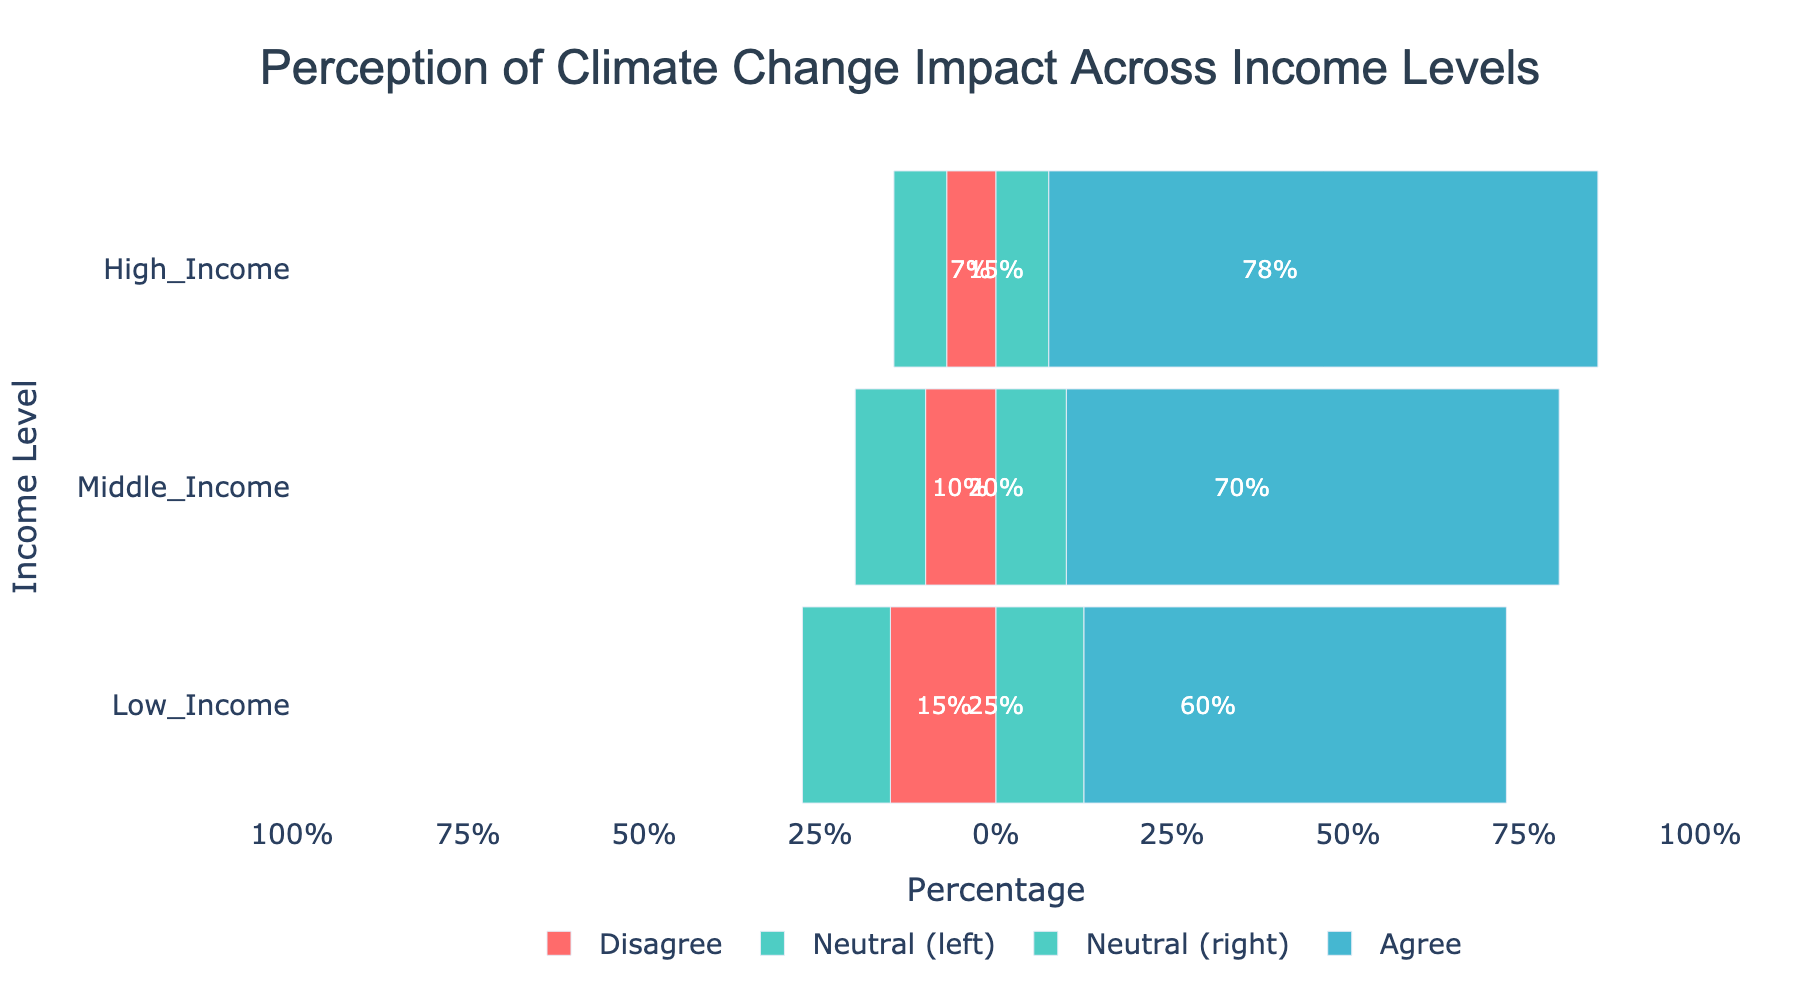What's the percentage of people who 'Agree' in the High Income level? To find this, look at the 'Agree' bar for the High Income level. The bar is labeled as 35%, which is the percentage of people who agree.
Answer: 35% Which income level has the highest percentage of people who 'Strongly Agree'? The income level with the highest 'Strongly Agree' percentage can be found by comparing the blue bars labeled 'Strongly Agree' across all income levels. The High Income level has the highest blue bar at 43%.
Answer: High Income What's the total percentage of people who are 'Neutral' in all income levels? Sum the 'Neutral' percentages across all income levels: 25% (Low Income) + 20% (Middle Income) + 15% (High Income) = 60%.
Answer: 60% Compare the total percentages of 'Strongly Disagree' and 'Strongly Agree' in the Low Income level. In the Low Income level, 'Strongly Disagree' is 5% and 'Strongly Agree' is 30%. The difference is 30% - 5% = 25%.
Answer: 25% Among all income levels, which one has the lowest percentage of people who 'Disagree'? Check the 'Disagree' percentages (seen in red bars) across all income levels. The High Income level has the lowest at 5%.
Answer: High Income What is the combined percentage of people who either 'Agree' or 'Strongly Agree' in the Middle Income level? The percentage who 'Agree' in Middle Income is 40%, and 'Strongly Agree' is 30%. So, 40% + 30% = 70%.
Answer: 70% Which income level has the most balanced perception, i.e., the closest combined 'Agree' and 'Disagree' percentages? Calculate the difference between combined 'Agree' and 'Disagree' percentages for each income level. Low Income: 60% - 15% = 45%, Middle Income: 70% - 10% = 60%, High Income: 78% - 7% = 71%. The lowest difference is for Low Income, making it the most balanced.
Answer: Low Income What's the total percentage of people who either 'Disagree' or 'Strongly Disagree' in the Middle Income level? The percentage who 'Disagree' in Middle Income is 7% and 'Strongly Disagree' is 3%. So, 7% + 3% = 10%.
Answer: 10% How does the percentage of people who are 'Neutral' in the Low Income level compare to those in the High Income level? In Low Income, the 'Neutral' percentage is 25%, and in High Income, it is 15%. The difference is 25% - 15% = 10%.
Answer: 10% What is the visual difference in the lengths of the 'Neutral' bars for Middle Income and High Income? The 'Neutral' bar length for Middle Income is 20%, and for High Income, it is 15%. The visual length difference is 20% - 15% = 5%.
Answer: 5% 